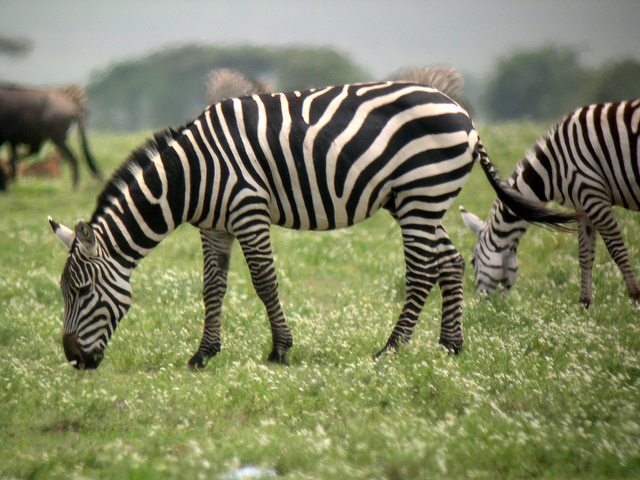Describe a possible daily routine for the zebras in this image. The daily routine of the zebras in this image likely begins at dawn. As the sun rises, the zebras start to become active, shaking off the cool of the night. They begin their day by grazing, taking advantage of the early morning’s temperate climate.

Throughout the morning, they continue to graze while staying alert for any signs of predators. By midday, the rising temperatures prompt the zebras to seek shade. They typically gather under trees or tall shrubs to rest and conserve energy, occasionally engaging in social behaviors like grooming or nuzzling each other.

In the late afternoon, when the heat begins to wane, the zebras resume grazing, taking in more food to maintain their energy levels. As evening approaches, they start moving towards their sleeping grounds, often sticking close together for safety.

Nights are cautious times for zebras. They usually sleep in shorter intervals, remaining semi-alert. The promise of a new day brings them back into the cycle of grazing, socializing, and staying vigilant for any dangers lurking in the savanna. Pretend you are a zebra in the image. Write a diary entry about an unusual event from your day. Dear Diary,

Today was unlike any other. The day began just like it always does, with the warmth of the rising sun nudging us awake. We started grazing, and everything seemed normal - the grass was plentiful, and the air was still. But then something extraordinary happened.

While we were grazing near the edge of the plains, we discovered a large, strange object glimmering in the sunlight. We all approached it cautiously, ears twitching and eyes wide with curiosity. It turned out to be a piece of metal, unlike anything we had seen before. None of us knew how it got there. Some of the herd thought it might be a sign from the sky spirits, while others believed it came from the two-legged creatures that roam occasionally.

As we gathered around, we noticed an unusual scent in the area – it was the scent of a predator, but not the typical lions or cheetahs we are familiar with. This scent was different, almost mechanical. Our leader decided it was best to move away quickly. We trotted back to our familiar grazing grounds, but the strange encounter left an air of mystery among us.

I overheard the older zebras talking about this well into the afternoon as we rested under the trees. Today ended with no other incidents, but my mind keeps returning to that shiny object and the peculiar scent. I wonder if we will ever come across something like it again.

Until next time,
A Curious Zebra 